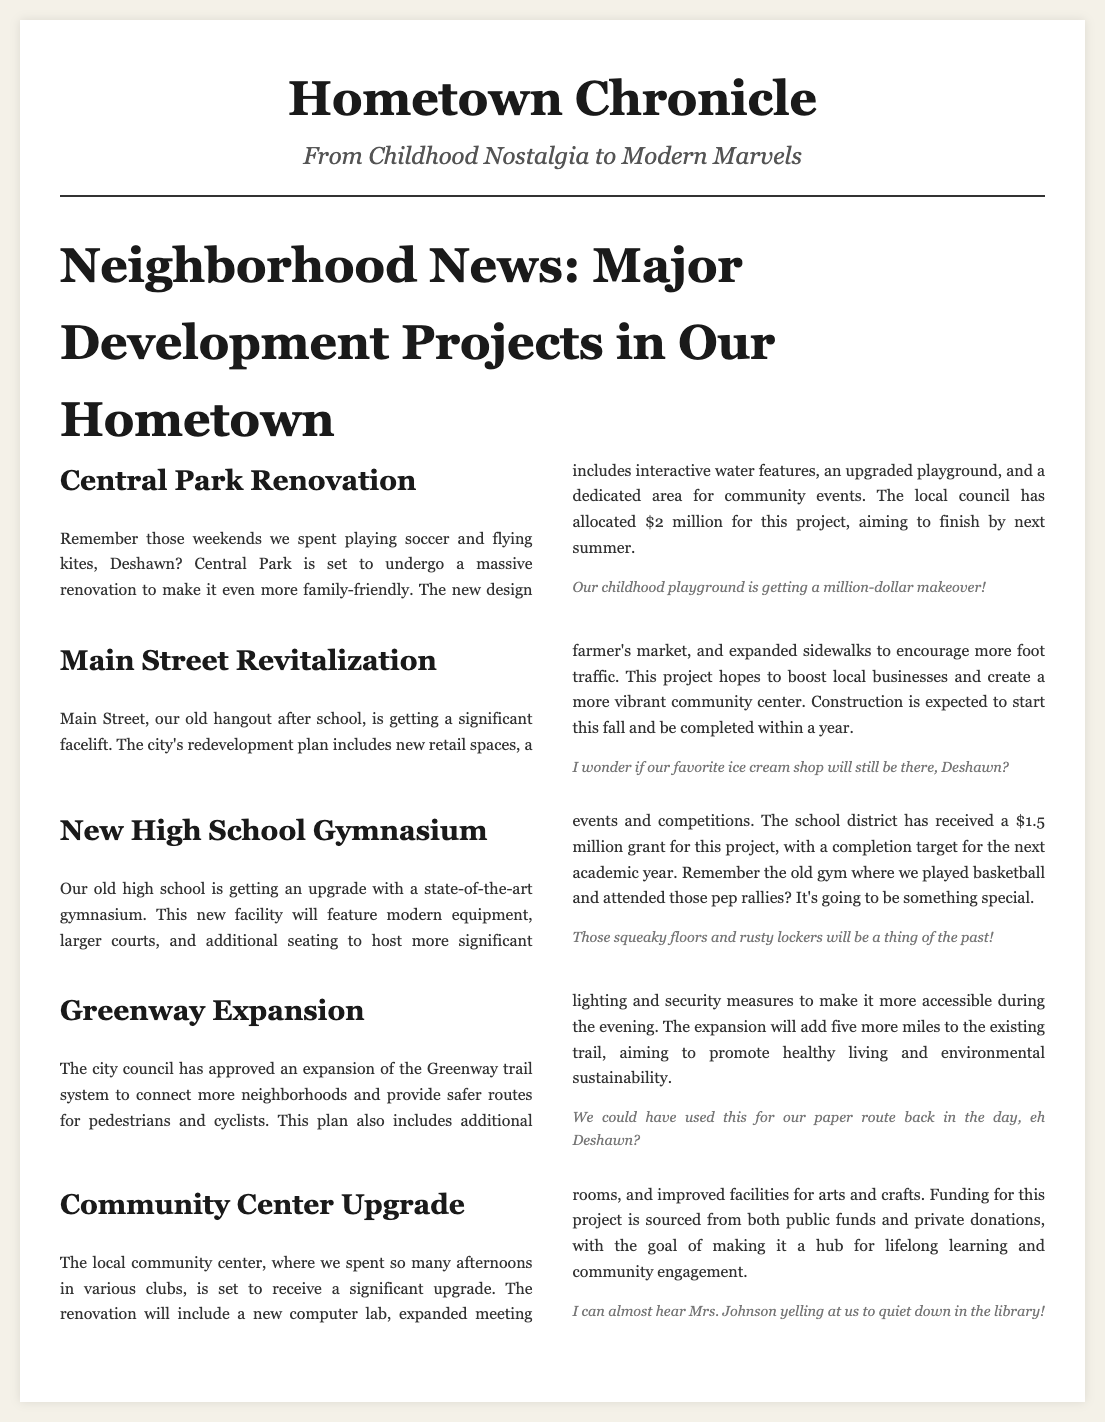What is the budget allocated for Central Park renovation? The budget allocated for Central Park renovation is mentioned in the section, which states that the local council has allocated $2 million for this project.
Answer: $2 million When is construction expected to start for Main Street revitalization? The timeline for construction of Main Street revitalization is provided in the section where it states that construction is expected to start this fall.
Answer: this fall What new features will the high school gymnasium have? The new high school gymnasium is described to have modern equipment, larger courts, and additional seating among other updated facilities.
Answer: modern equipment, larger courts, additional seating How many miles will the Greenway expansion add to the existing trail? The document states that the Greenway expansion will add five more miles to the existing trail.
Answer: five more miles What is a goal of the community center upgrade? The document mentions that one of the goals of the community center upgrade is to make it a hub for lifelong learning and community engagement.
Answer: hub for lifelong learning and community engagement What type of upgrade is Central Park receiving? The upgrade being received by Central Park is a renovation aimed at making it more family-friendly.
Answer: renovation What is a unique aspect of the projects mentioned in the article? A unique aspect of the projects mentioned is that they are focused on improving community spaces and facilities in the hometown.
Answer: improving community spaces and facilities 